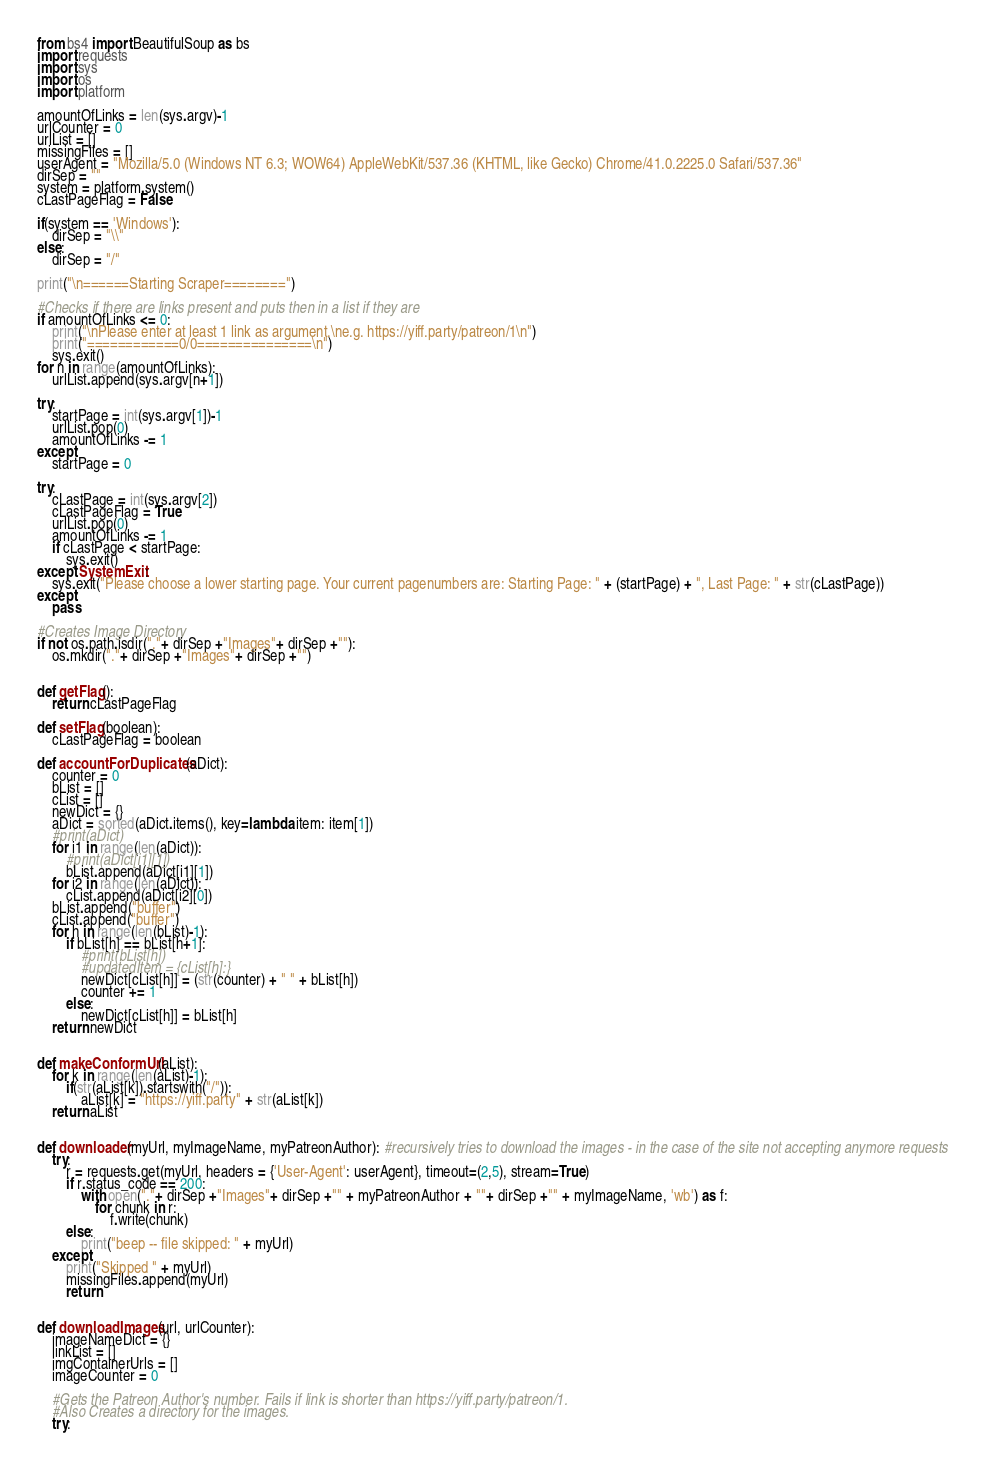<code> <loc_0><loc_0><loc_500><loc_500><_Python_>from bs4 import BeautifulSoup as bs
import requests
import sys
import os
import platform

amountOfLinks = len(sys.argv)-1
urlCounter = 0
urlList = []
missingFiles = []
userAgent = "Mozilla/5.0 (Windows NT 6.3; WOW64) AppleWebKit/537.36 (KHTML, like Gecko) Chrome/41.0.2225.0 Safari/537.36"
dirSep = ""
system = platform.system()
cLastPageFlag = False

if(system == 'Windows'):
    dirSep = "\\"
else:
    dirSep = "/"

print("\n======Starting Scraper========")

#Checks if there are links present and puts then in a list if they are
if amountOfLinks <= 0:
    print("\nPlease enter at least 1 link as argument.\ne.g. https://yiff.party/patreon/1\n")
    print("============0/0===============\n")
    sys.exit()
for n in range(amountOfLinks):
    urlList.append(sys.argv[n+1])

try:
    startPage = int(sys.argv[1])-1
    urlList.pop(0)
    amountOfLinks -= 1
except:
    startPage = 0

try:
    cLastPage = int(sys.argv[2])
    cLastPageFlag = True
    urlList.pop(0)
    amountOfLinks -= 1
    if cLastPage < startPage:
        sys.exit()
except SystemExit:
    sys.exit("Please choose a lower starting page. Your current pagenumbers are: Starting Page: " + (startPage) + ", Last Page: " + str(cLastPage))
except:
    pass

#Creates Image Directory
if not os.path.isdir("."+ dirSep +"Images"+ dirSep +""):
    os.mkdir("."+ dirSep +"Images"+ dirSep +"")


def getFlag():
    return cLastPageFlag

def setFlag(boolean):
    cLastPageFlag = boolean

def accountForDuplicates(aDict):
    counter = 0
    bList = [] 
    cList = []
    newDict = {}
    aDict = sorted(aDict.items(), key=lambda item: item[1])
    #print(aDict)
    for i1 in range(len(aDict)):
        #print(aDict[i1][1])
        bList.append(aDict[i1][1])
    for i2 in range(len(aDict)):
        cList.append(aDict[i2][0])
    bList.append("buffer")
    cList.append("buffer")
    for h in range(len(bList)-1):
        if bList[h] == bList[h+1]:
            #print(bList[h])
            #updatedItem = {cList[h]:}
            newDict[cList[h]] = (str(counter) + " " + bList[h])
            counter += 1
        else:
            newDict[cList[h]] = bList[h]
    return newDict
        

def makeConformUrl(aList):
    for k in range(len(aList)-1):
        if(str(aList[k]).startswith("/")):
            aList[k] = "https://yiff.party" + str(aList[k])
    return aList


def downloader(myUrl, myImageName, myPatreonAuthor): #recursively tries to download the images - in the case of the site not accepting anymore requests
    try:
        r = requests.get(myUrl, headers = {'User-Agent': userAgent}, timeout=(2,5), stream=True)
        if r.status_code == 200:
            with open("."+ dirSep +"Images"+ dirSep +"" + myPatreonAuthor + ""+ dirSep +"" + myImageName, 'wb') as f:
                for chunk in r:
                    f.write(chunk)
        else:
            print("beep -- file skipped: " + myUrl)
    except:
        print("Skipped " + myUrl)
        missingFiles.append(myUrl)
        return


def downloadImages(url, urlCounter):
    imageNameDict = {}
    linkList = []
    imgContainerUrls = []
    imageCounter = 0

    #Gets the Patreon Author's number. Fails if link is shorter than https://yiff.party/patreon/1.
    #Also Creates a directory for the images.
    try:    </code> 